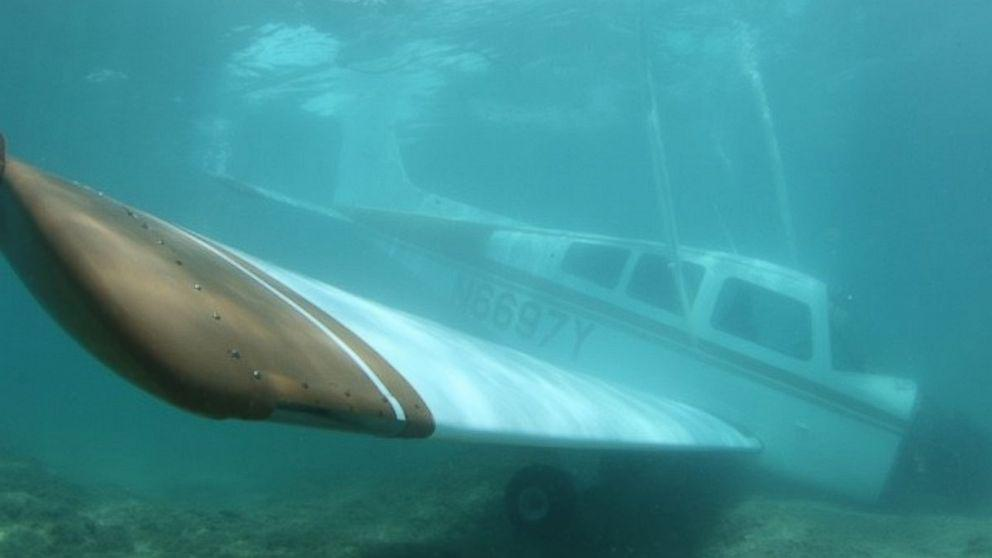Can you tell me about the vehicle submerged in the water? Certainly! The image shows a light aircraft, specifically a small single-engine airplane, submerged underwater, which seems like an unusual and intriguing situation. It may suggest an accidental water landing or an intentional sinking for creating an artificial reef. 